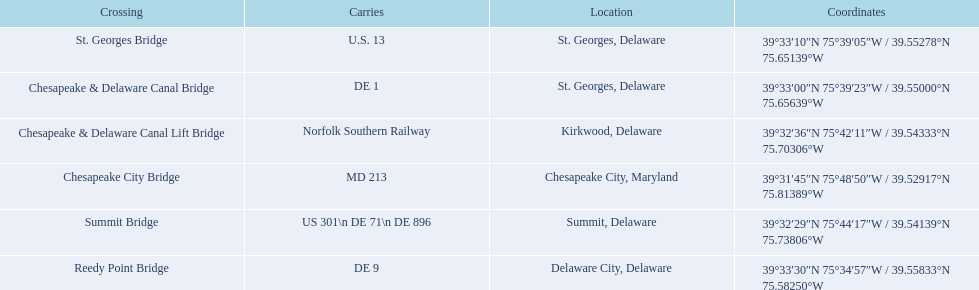How many crossings are in maryland? 1. 